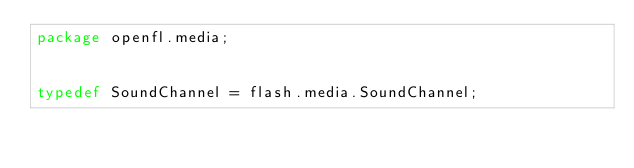<code> <loc_0><loc_0><loc_500><loc_500><_Haxe_>package openfl.media;


typedef SoundChannel = flash.media.SoundChannel;</code> 